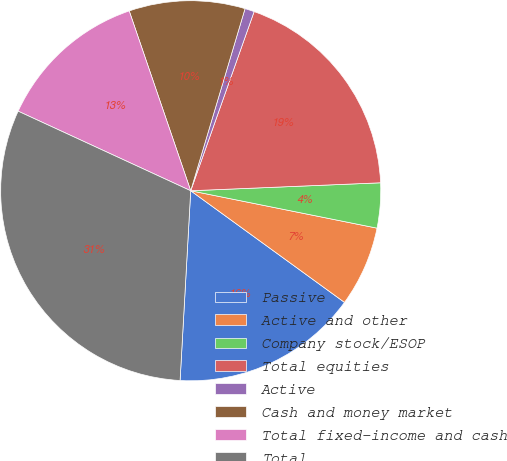Convert chart to OTSL. <chart><loc_0><loc_0><loc_500><loc_500><pie_chart><fcel>Passive<fcel>Active and other<fcel>Company stock/ESOP<fcel>Total equities<fcel>Active<fcel>Cash and money market<fcel>Total fixed-income and cash<fcel>Total<nl><fcel>15.9%<fcel>6.84%<fcel>3.82%<fcel>18.92%<fcel>0.8%<fcel>9.86%<fcel>12.88%<fcel>30.99%<nl></chart> 